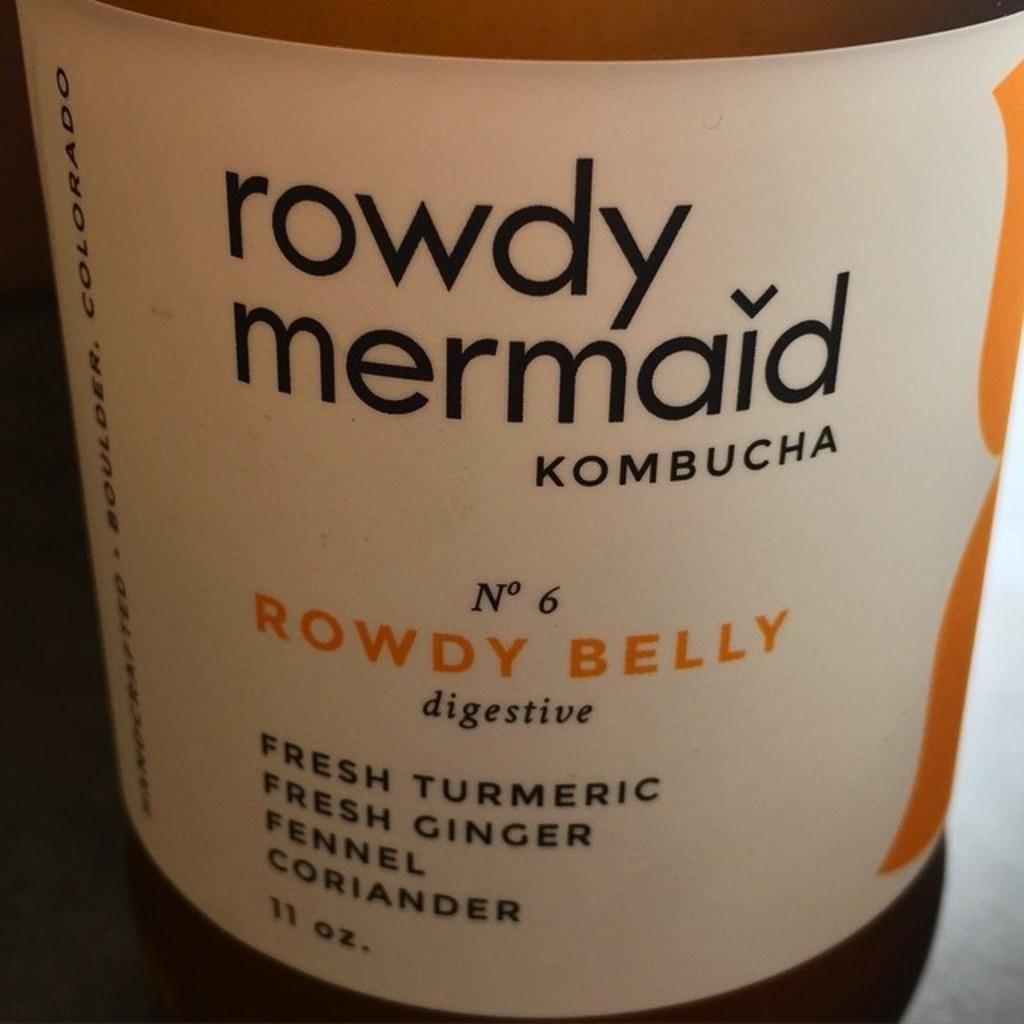Provide a one-sentence caption for the provided image. An 11 oz bottle of rowdy mermaid kombucha. 